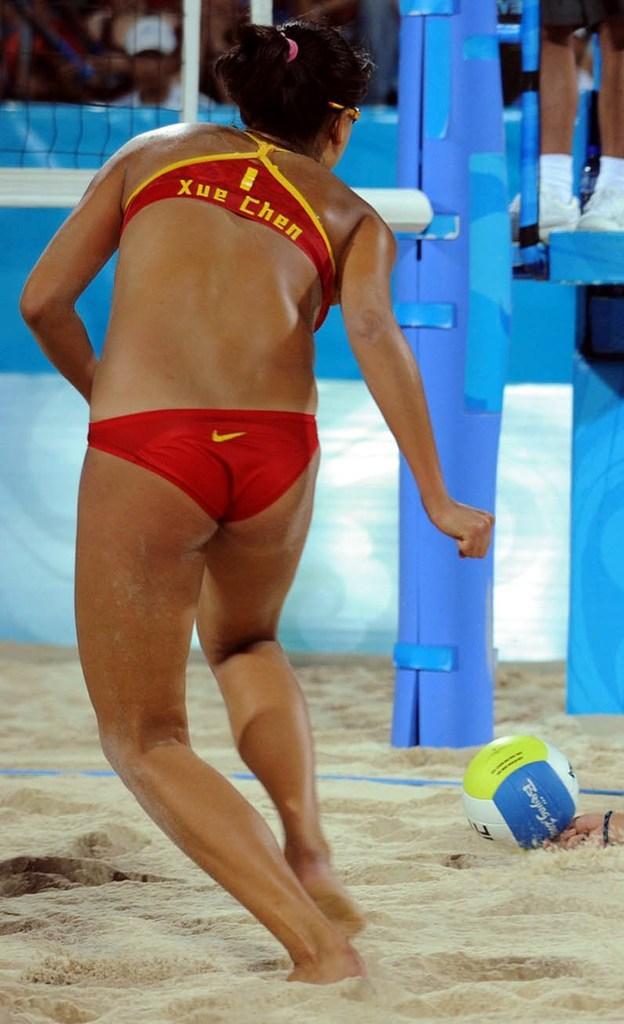Can you describe this image briefly? In this image, on the left there is a woman, she is running. At the bottom there is a ball, sand, person. In the background there are people, net. 